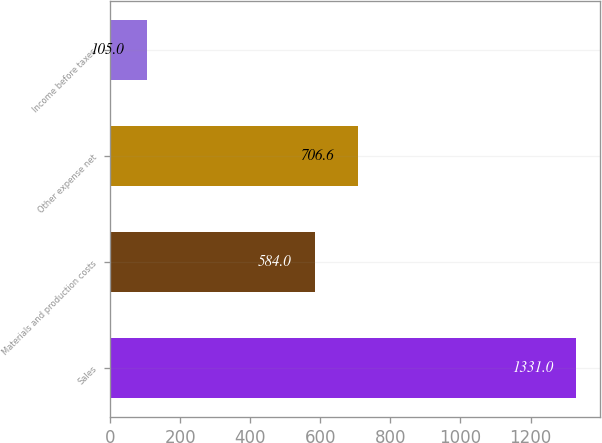Convert chart to OTSL. <chart><loc_0><loc_0><loc_500><loc_500><bar_chart><fcel>Sales<fcel>Materials and production costs<fcel>Other expense net<fcel>Income before taxes<nl><fcel>1331<fcel>584<fcel>706.6<fcel>105<nl></chart> 